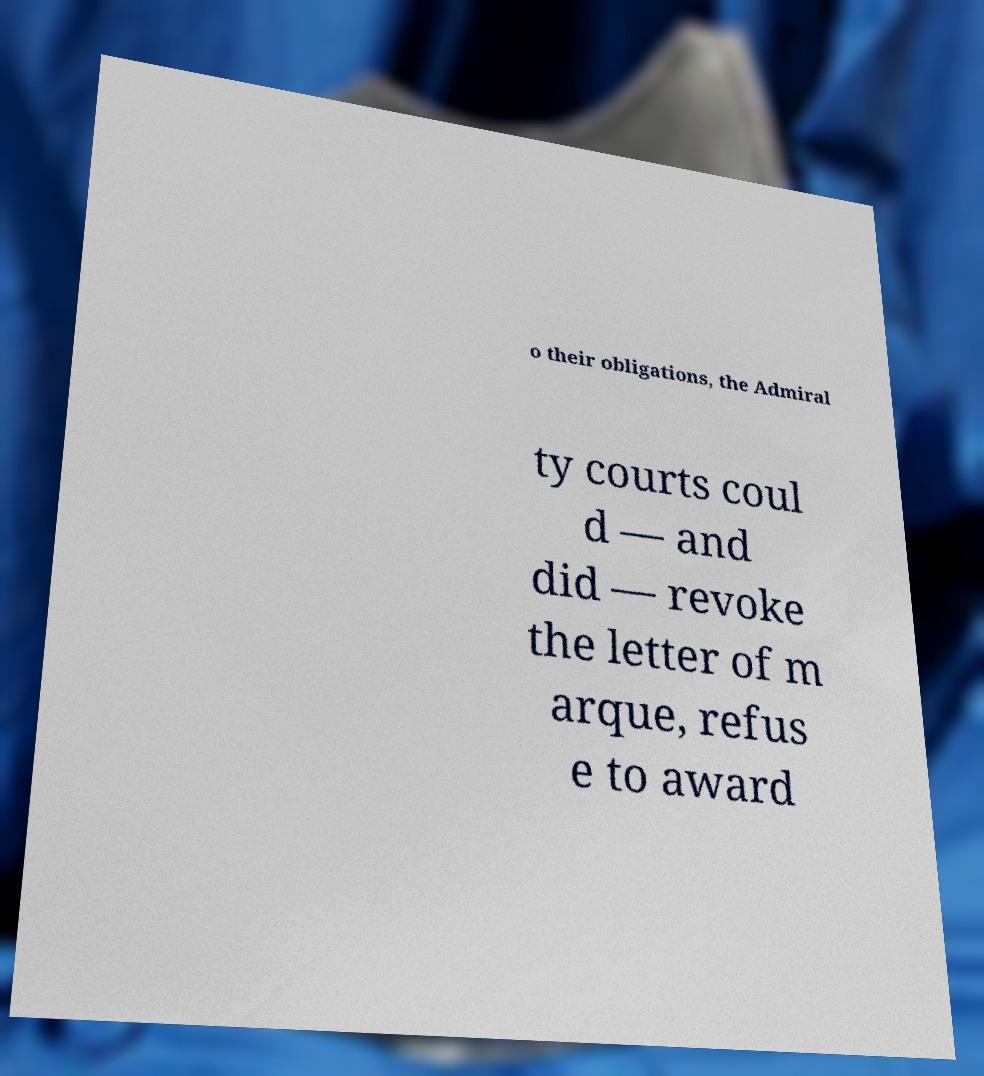Could you extract and type out the text from this image? o their obligations, the Admiral ty courts coul d — and did — revoke the letter of m arque, refus e to award 